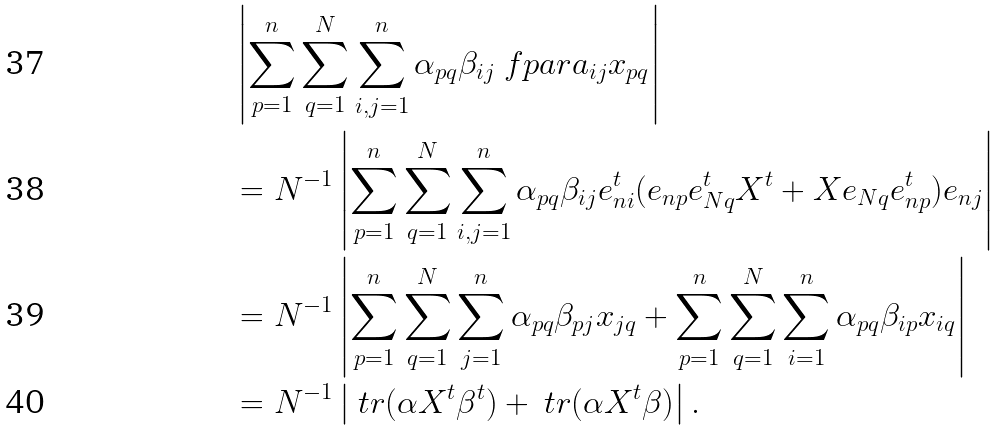<formula> <loc_0><loc_0><loc_500><loc_500>& \left | \sum _ { p = 1 } ^ { n } \sum _ { q = 1 } ^ { N } \sum _ { i , j = 1 } ^ { n } \alpha _ { p q } \beta _ { i j } \ f p a r { a _ { i j } } { x _ { p q } } \right | \\ & = N ^ { - 1 } \left | \sum _ { p = 1 } ^ { n } \sum _ { q = 1 } ^ { N } \sum _ { i , j = 1 } ^ { n } \alpha _ { p q } \beta _ { i j } e _ { n i } ^ { t } ( e _ { n p } e _ { N q } ^ { t } X ^ { t } + X e _ { N q } e _ { n p } ^ { t } ) e _ { n j } \right | \\ & = N ^ { - 1 } \left | \sum _ { p = 1 } ^ { n } \sum _ { q = 1 } ^ { N } \sum _ { j = 1 } ^ { n } \alpha _ { p q } \beta _ { p j } x _ { j q } + \sum _ { p = 1 } ^ { n } \sum _ { q = 1 } ^ { N } \sum _ { i = 1 } ^ { n } \alpha _ { p q } \beta _ { i p } x _ { i q } \right | \\ & = N ^ { - 1 } \left | \ t r ( \alpha X ^ { t } \beta ^ { t } ) + \ t r ( \alpha X ^ { t } \beta ) \right | .</formula> 